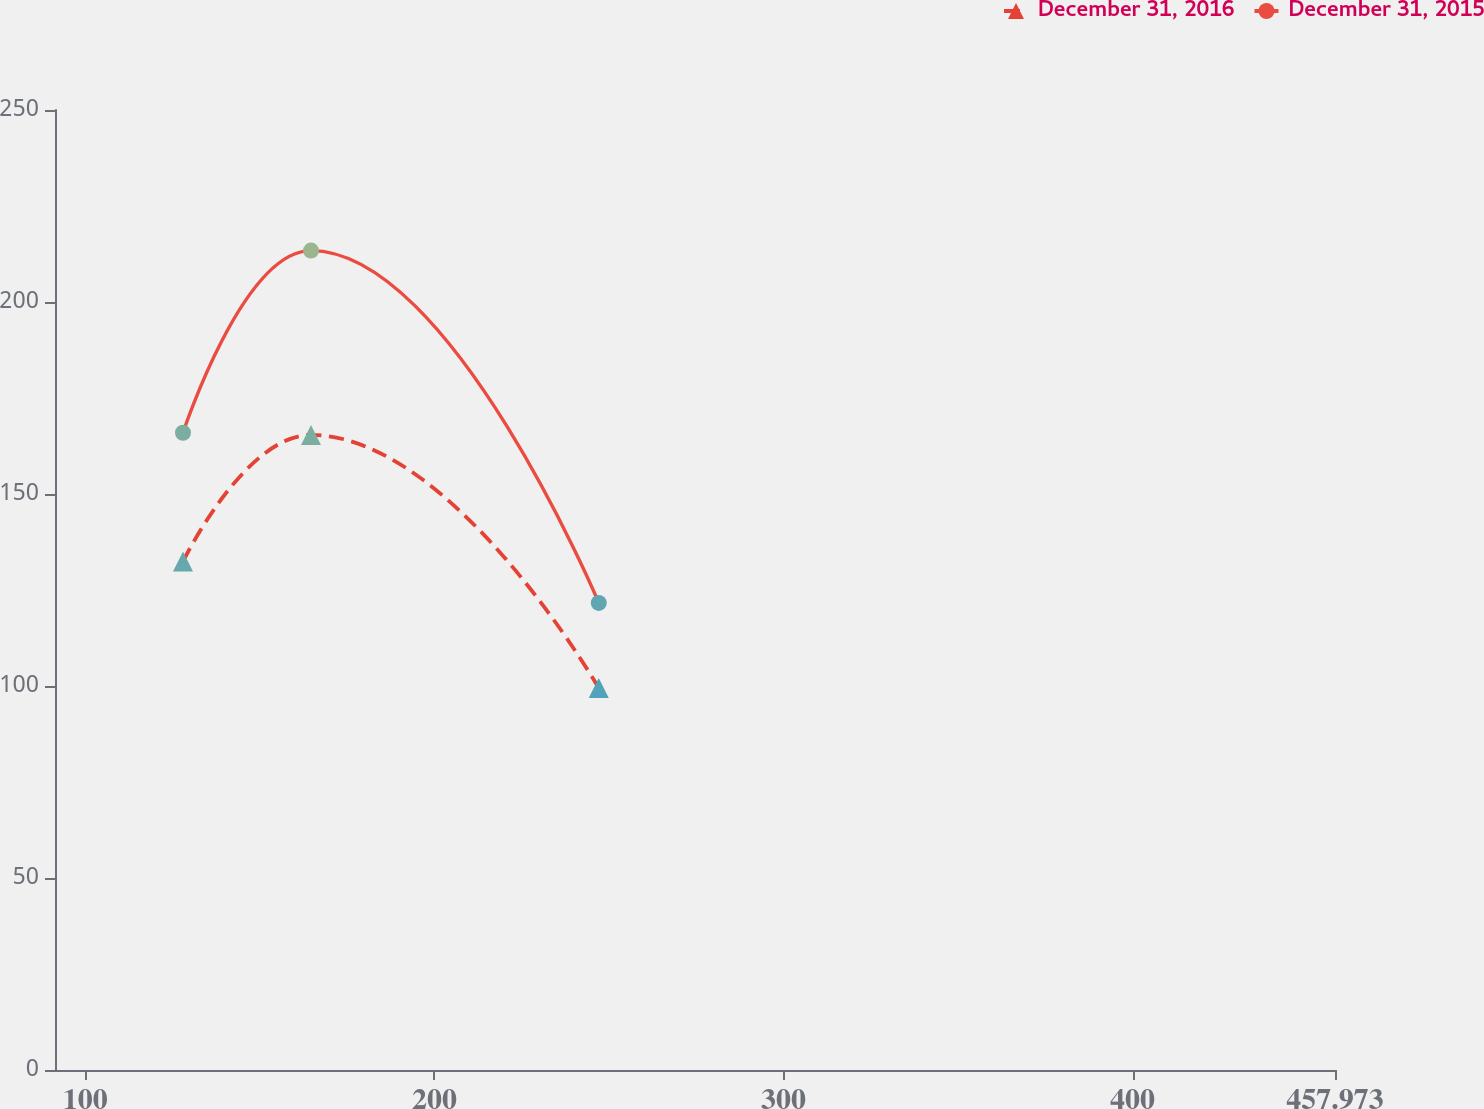Convert chart. <chart><loc_0><loc_0><loc_500><loc_500><line_chart><ecel><fcel>December 31, 2016<fcel>December 31, 2015<nl><fcel>127.97<fcel>132.42<fcel>165.95<nl><fcel>164.64<fcel>165.38<fcel>213.38<nl><fcel>247.07<fcel>99.46<fcel>121.64<nl><fcel>494.64<fcel>429.09<fcel>564.74<nl></chart> 